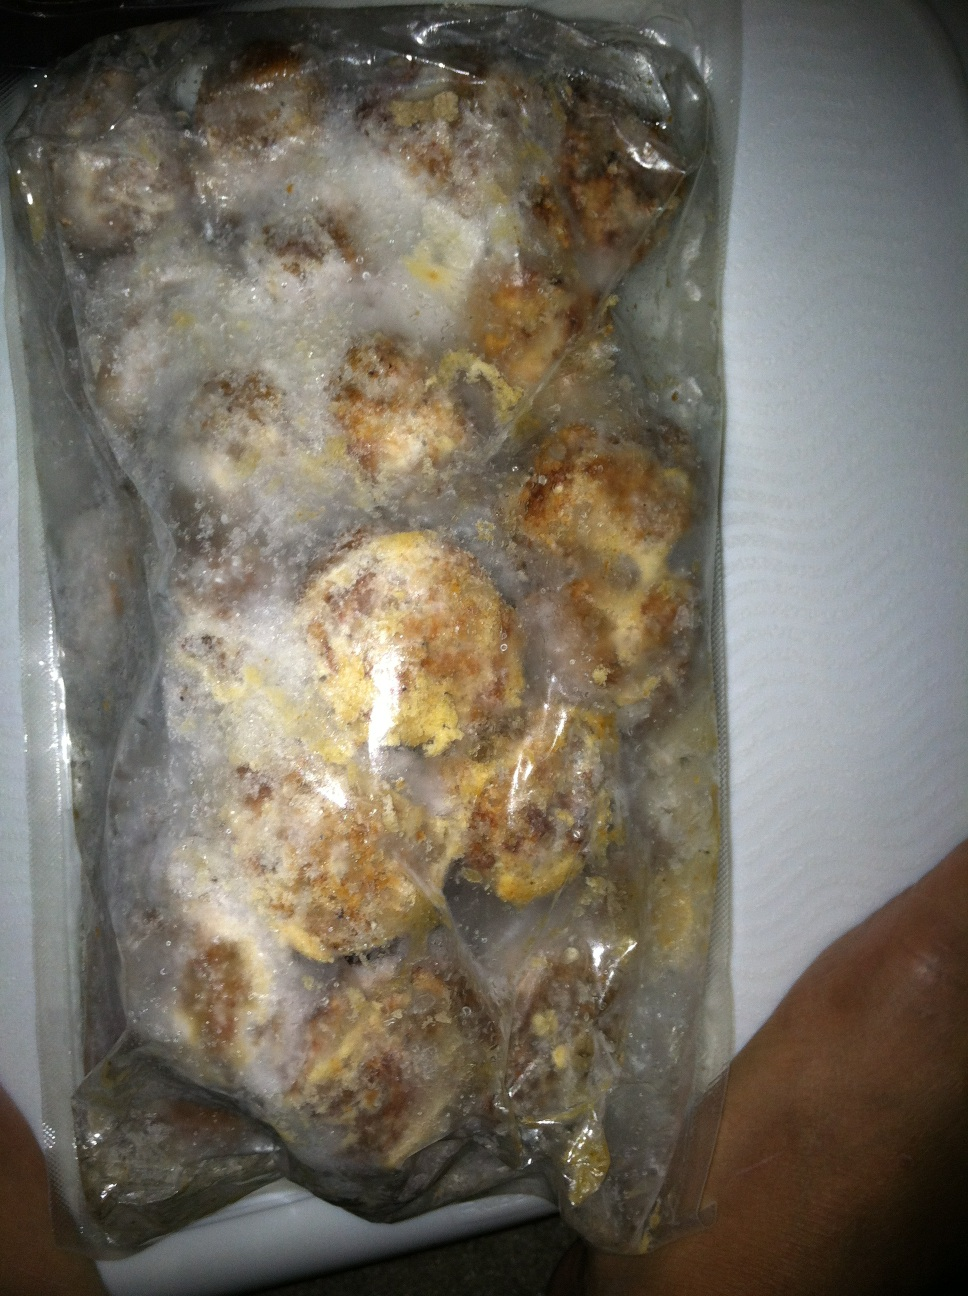Imagine a creative storyline involving this frozen package. What is its journey from the kitchen to a grand feast? Once upon a time, in a quaint little home, this package of frozen meatballs was carefully crafted by a loving grandmother. She infused each meatball with secret herbs and spices from her ancient family recipe. The meatballs were then frozen to preserve their delicate flavors. One day, they were discovered by her grandson, who was aspiring to become a chef. He decided to take these meatballs to a renowned cooking competition. With a burst of creativity, he created a gourmet dish that amazed the judges. These humble meatballs became the highlight of a grand feast, earning him the title of Best New Chef. 